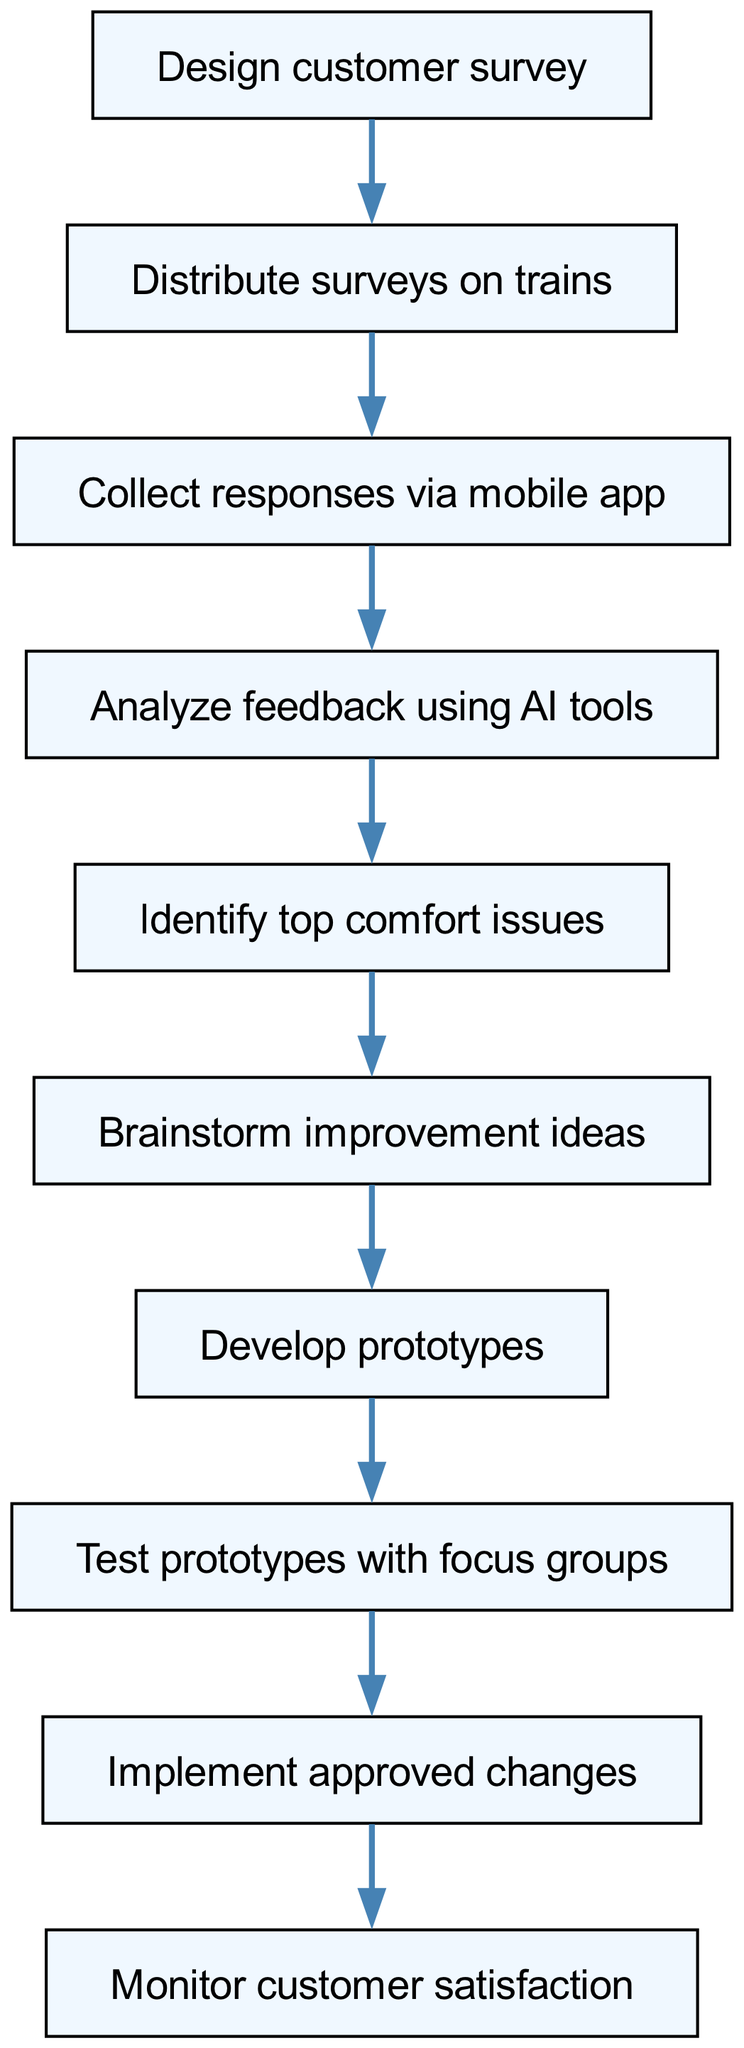What is the first step in the process? The first step in the flow chart is to "Design customer survey," which is the starting node.
Answer: Design customer survey How many nodes are there in the diagram? The flow chart consists of 10 nodes, each representing a step in the customer feedback collection and analysis process.
Answer: 10 What is the final step in the process? The last step in the flow chart is "Monitor customer satisfaction," which checks the effectiveness of the changes implemented.
Answer: Monitor customer satisfaction Which step follows the analysis of feedback? After analyzing feedback using AI tools, the next step is to "Identify top comfort issues," indicating a focused approach to address the most significant concerns.
Answer: Identify top comfort issues What process is involved after brainstorming improvement ideas? Following the brainstorming of improvement ideas, the next step is "Develop prototypes," showing a move from conceptualizing to actual development.
Answer: Develop prototypes How many steps are there between distributing surveys and implementing changes? There are 6 steps between distributing surveys on trains and implementing approved changes, indicating a thorough process from feedback collection to implementation.
Answer: 6 Which node specifically addresses customer responses collection? The node titled "Collect responses via mobile app" directly refers to the step in which customer feedback is gathered.
Answer: Collect responses via mobile app What is the relationship between analyzing feedback and identifying issues? Analyzing feedback leads directly to identifying top comfort issues, showing a cause-and-effect relationship in the feedback process.
Answer: Cause-and-effect relationship What comes before testing prototypes? Before testing prototypes with focus groups, the process involves "Develop prototypes," indicating a sequential development phase that prepares for evaluation.
Answer: Develop prototypes 